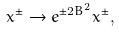<formula> <loc_0><loc_0><loc_500><loc_500>x ^ { \pm } \to e ^ { \pm 2 B ^ { 2 } } x ^ { \pm } ,</formula> 